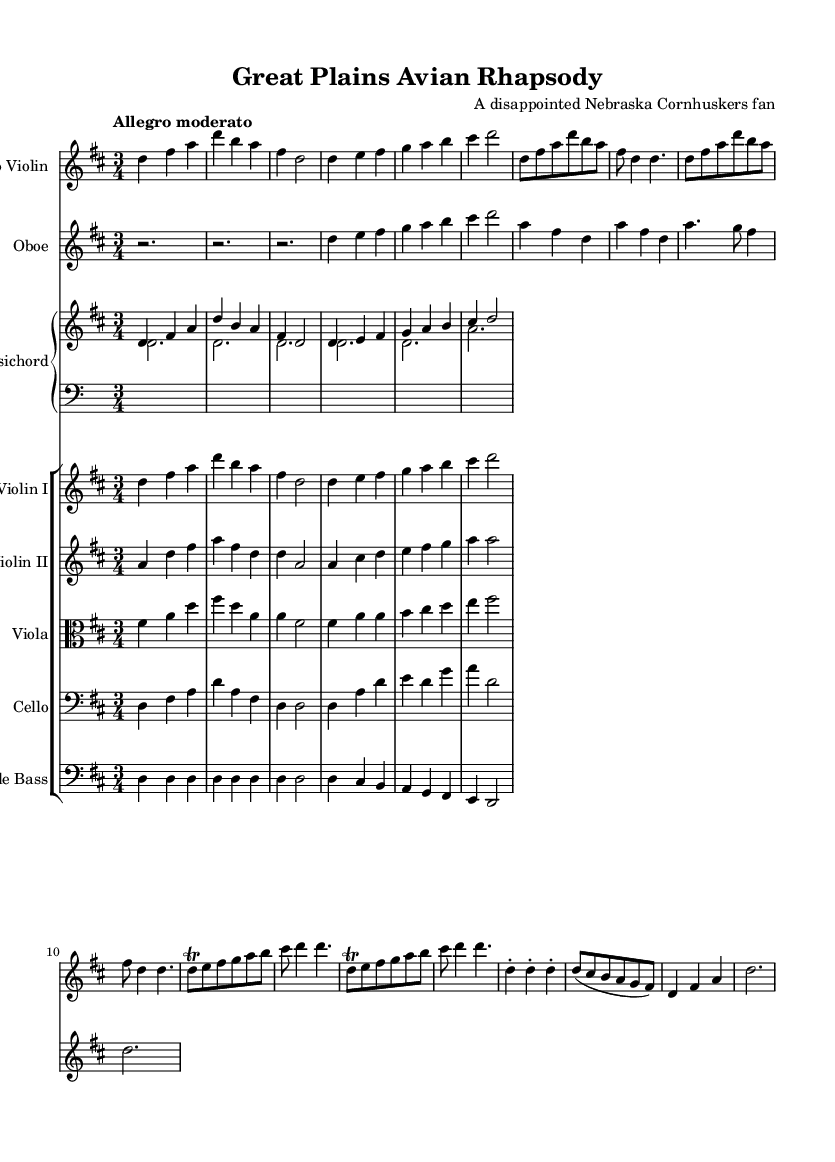What is the key signature of this music? The key signature is D major, which has two sharps (F# and C#). This can be identified by looking at the key signature notation at the beginning of the sheet music.
Answer: D major What is the time signature of this music? The time signature is 3/4, indicating there are three beats in a measure and the quarter note gets one beat. This can be found next to the key signature at the start of the score.
Answer: 3/4 What is the tempo marking for this piece? The tempo marking is "Allegro moderato," which suggests a moderately fast pace of performance. This is specified directly above the staff at the beginning of the piece.
Answer: Allegro moderato How many measures are there in the violin solo? The violin solo contains 16 measures. By counting the number of groups divided by the bar lines in the solo violin section, you can determine the total count.
Answer: 16 Which instruments are featured in this concerto? The instruments featured in this concerto include Solo Violin, Oboe, Harpsichord, Violin I, Violin II, Viola, Cello, and Double Bass. You can find this information by examining the instrument names included in the score layout.
Answer: Solo Violin, Oboe, Harpsichord, Violin I, Violin II, Viola, Cello, Double Bass What type of ornamentation is used in the solo violin part? The solo violin part features a trill ornamentation, indicated by the "tr" symbol above the note in the score. This ornamentation typically suggests rapid alternation between the main note and the note above.
Answer: Trill What is the form of this concerto? The form of this concerto is typically a three-movement structure, common in the Baroque period. Each movement typically contrasts in tempo and mood, which can be inferred from the structure and tempo annotations, though not explicitly stated in the excerpt.
Answer: Three-movement 